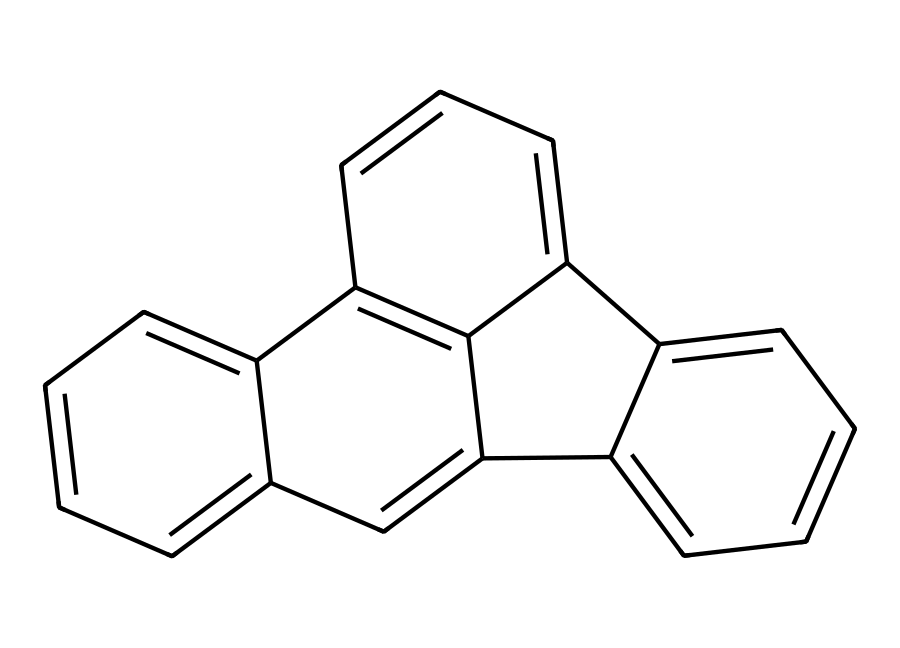How many rings are in this PAH structure? By examining the provided SMILES representation, we can identify the number of distinct aromatic rings in the structure. The structure forms four interconnected rings based on the connections indicated.
Answer: four What is the fused ring system in this compound? The SMILES representation shows how different benzene rings are fused together; the presence of shared carbon atoms indicates a fused ring system in this compound. The specific arrangement leads to a structure composed of phenanthrene and anthracene, thus being part of the polycyclic aromatic hydrocarbons.
Answer: phenanthrene and anthracene What is the total number of carbon atoms in this compound? Counting the carbon atoms in the given SMILES, each "c" represents a carbon in an aromatic ring. There are a total of 18 carbon atoms in the structure visualized from the SMILES representation.
Answer: eighteen Does this PAH contain any heteroatoms? The presence of "c" in the SMILES representation indicates only carbon atoms and there is no indication of any heteroatoms (like nitrogen or oxygen) present in the structure, confirming it's purely carbon-based.
Answer: no What is the category of organic compounds this structure belongs to? Given the presence of multiple fused aromatic rings as indicated in the SMILES, where the entire structure predominantly consists of aromatic hydrocarbons bonded together without functional groups, it defines the compound as a polycyclic aromatic hydrocarbon.
Answer: polycyclic aromatic hydrocarbon 